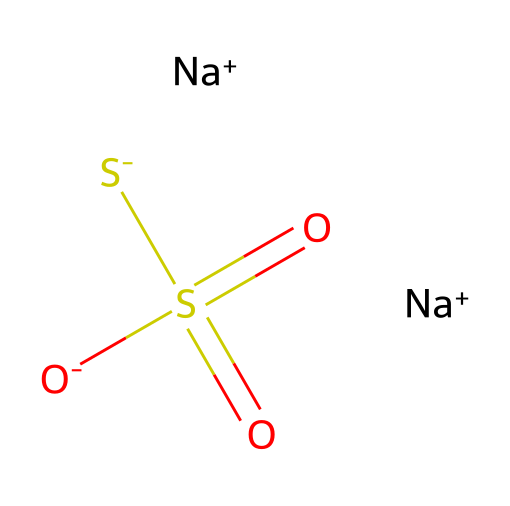What is the total number of sodium atoms in the structure? By examining the SMILES representation, we can see two instances of "[Na+]", which indicates that there are two sodium atoms present in this chemical structure.
Answer: 2 How many sulfur atoms are in this compound? The SMILES includes "S" written twice in the arrangement, each corresponding to a sulfur atom. Therefore, there are two sulfur atoms in the molecular structure.
Answer: 2 What is the oxidation state of sulfur in sodium thiosulfate? In sodium thiosulfate, the sulfur atoms are typically at two different oxidation states. One sulfur is in the +6 oxidation state (central sulfur with double bonds to two oxygen atoms), and the other is in the -2 oxidation state (the "thio" sulfur). Therefore, considering both, the average can indicate the compound's functionality.
Answer: +6 and -2 Which ion forms the basic part of sodium thiosulfate? The basic part of sodium thiosulfate is the thiosulfate anion itself, represented by "[O-]S(=O)(=O)[S-]", which indicates its structure and charge. This is sufficient to identify the thiosulfate as the essential functional part of the chemical.
Answer: thiosulfate Is sodium thiosulfate soluble in water? Sodium thiosulfate is known to be highly soluble in water due to the ionic nature of sodium and the polar characteristics of the thiosulfate ion, which enhances solubility in aqueous solutions.
Answer: yes What is the primary use of sodium thiosulfate in photography? Sodium thiosulfate is primarily used as a fixing agent in photography, as it helps to remove unexposed silver halides from photographic film, thus stabilizing the developed image.
Answer: fixing agent 